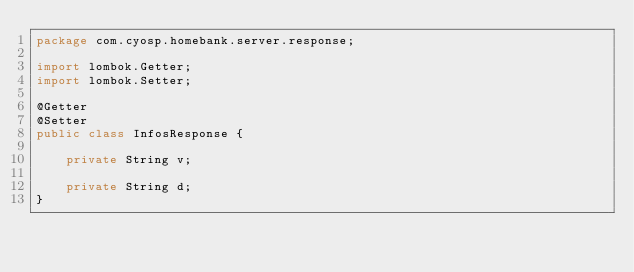<code> <loc_0><loc_0><loc_500><loc_500><_Java_>package com.cyosp.homebank.server.response;

import lombok.Getter;
import lombok.Setter;

@Getter
@Setter
public class InfosResponse {

    private String v;

    private String d;
}
</code> 